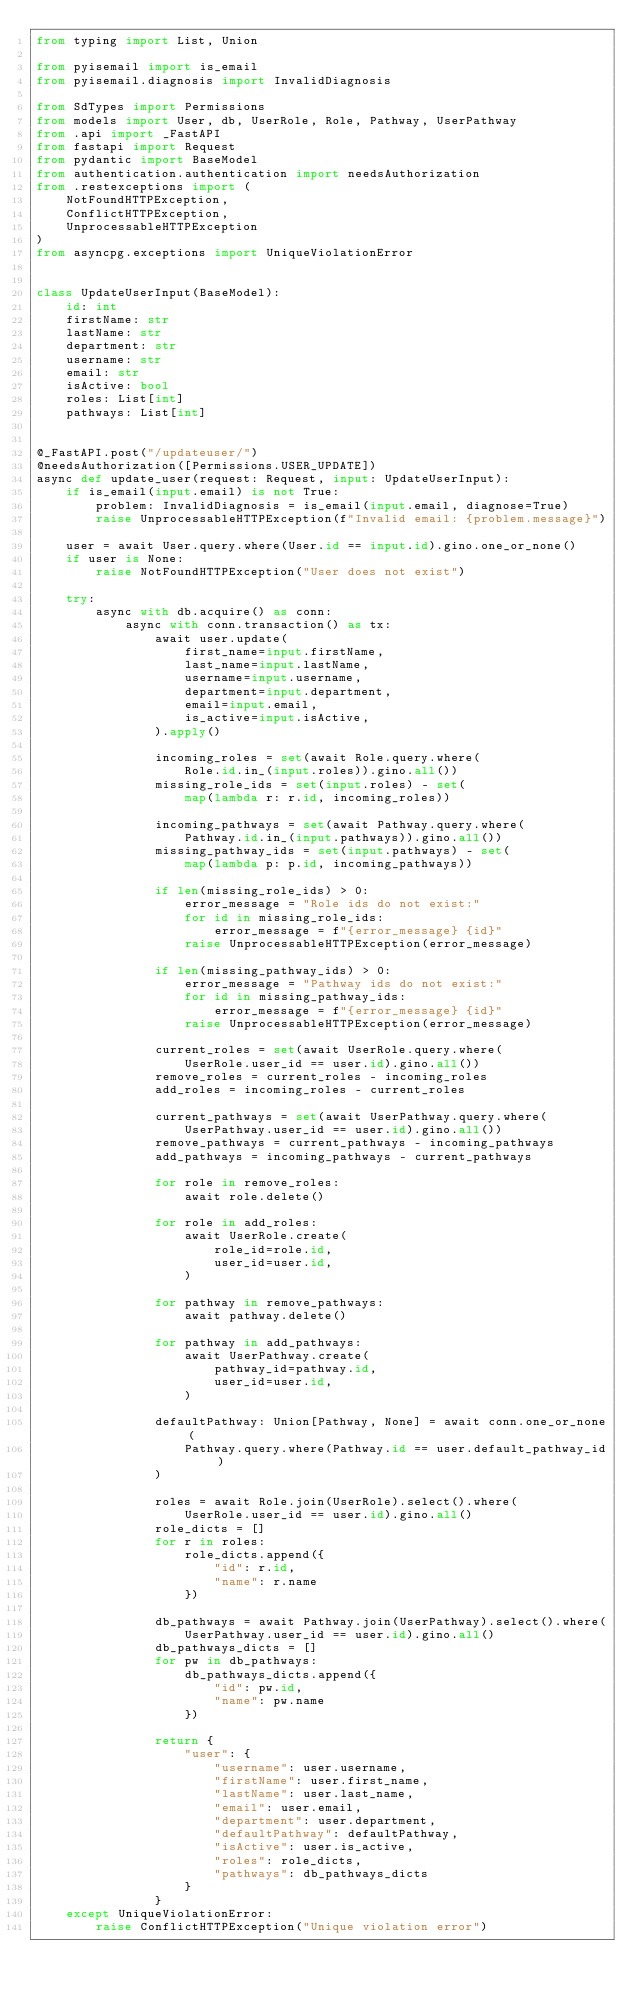<code> <loc_0><loc_0><loc_500><loc_500><_Python_>from typing import List, Union

from pyisemail import is_email
from pyisemail.diagnosis import InvalidDiagnosis

from SdTypes import Permissions
from models import User, db, UserRole, Role, Pathway, UserPathway
from .api import _FastAPI
from fastapi import Request
from pydantic import BaseModel
from authentication.authentication import needsAuthorization
from .restexceptions import (
    NotFoundHTTPException,
    ConflictHTTPException,
    UnprocessableHTTPException
)
from asyncpg.exceptions import UniqueViolationError


class UpdateUserInput(BaseModel):
    id: int
    firstName: str
    lastName: str
    department: str
    username: str
    email: str
    isActive: bool
    roles: List[int]
    pathways: List[int]


@_FastAPI.post("/updateuser/")
@needsAuthorization([Permissions.USER_UPDATE])
async def update_user(request: Request, input: UpdateUserInput):
    if is_email(input.email) is not True:
        problem: InvalidDiagnosis = is_email(input.email, diagnose=True)
        raise UnprocessableHTTPException(f"Invalid email: {problem.message}")

    user = await User.query.where(User.id == input.id).gino.one_or_none()
    if user is None:
        raise NotFoundHTTPException("User does not exist")

    try:
        async with db.acquire() as conn:
            async with conn.transaction() as tx:
                await user.update(
                    first_name=input.firstName,
                    last_name=input.lastName,
                    username=input.username,
                    department=input.department,
                    email=input.email,
                    is_active=input.isActive,
                ).apply()

                incoming_roles = set(await Role.query.where(
                    Role.id.in_(input.roles)).gino.all())
                missing_role_ids = set(input.roles) - set(
                    map(lambda r: r.id, incoming_roles))

                incoming_pathways = set(await Pathway.query.where(
                    Pathway.id.in_(input.pathways)).gino.all())
                missing_pathway_ids = set(input.pathways) - set(
                    map(lambda p: p.id, incoming_pathways))

                if len(missing_role_ids) > 0:
                    error_message = "Role ids do not exist:"
                    for id in missing_role_ids:
                        error_message = f"{error_message} {id}"
                    raise UnprocessableHTTPException(error_message)

                if len(missing_pathway_ids) > 0:
                    error_message = "Pathway ids do not exist:"
                    for id in missing_pathway_ids:
                        error_message = f"{error_message} {id}"
                    raise UnprocessableHTTPException(error_message)

                current_roles = set(await UserRole.query.where(
                    UserRole.user_id == user.id).gino.all())
                remove_roles = current_roles - incoming_roles
                add_roles = incoming_roles - current_roles

                current_pathways = set(await UserPathway.query.where(
                    UserPathway.user_id == user.id).gino.all())
                remove_pathways = current_pathways - incoming_pathways
                add_pathways = incoming_pathways - current_pathways

                for role in remove_roles:
                    await role.delete()

                for role in add_roles:
                    await UserRole.create(
                        role_id=role.id,
                        user_id=user.id,
                    )

                for pathway in remove_pathways:
                    await pathway.delete()

                for pathway in add_pathways:
                    await UserPathway.create(
                        pathway_id=pathway.id,
                        user_id=user.id,
                    )

                defaultPathway: Union[Pathway, None] = await conn.one_or_none(
                    Pathway.query.where(Pathway.id == user.default_pathway_id)
                )

                roles = await Role.join(UserRole).select().where(
                    UserRole.user_id == user.id).gino.all()
                role_dicts = []
                for r in roles:
                    role_dicts.append({
                        "id": r.id,
                        "name": r.name
                    })

                db_pathways = await Pathway.join(UserPathway).select().where(
                    UserPathway.user_id == user.id).gino.all()
                db_pathways_dicts = []
                for pw in db_pathways:
                    db_pathways_dicts.append({
                        "id": pw.id,
                        "name": pw.name
                    })

                return {
                    "user": {
                        "username": user.username,
                        "firstName": user.first_name,
                        "lastName": user.last_name,
                        "email": user.email,
                        "department": user.department,
                        "defaultPathway": defaultPathway,
                        "isActive": user.is_active,
                        "roles": role_dicts,
                        "pathways": db_pathways_dicts
                    }
                }
    except UniqueViolationError:
        raise ConflictHTTPException("Unique violation error")
</code> 